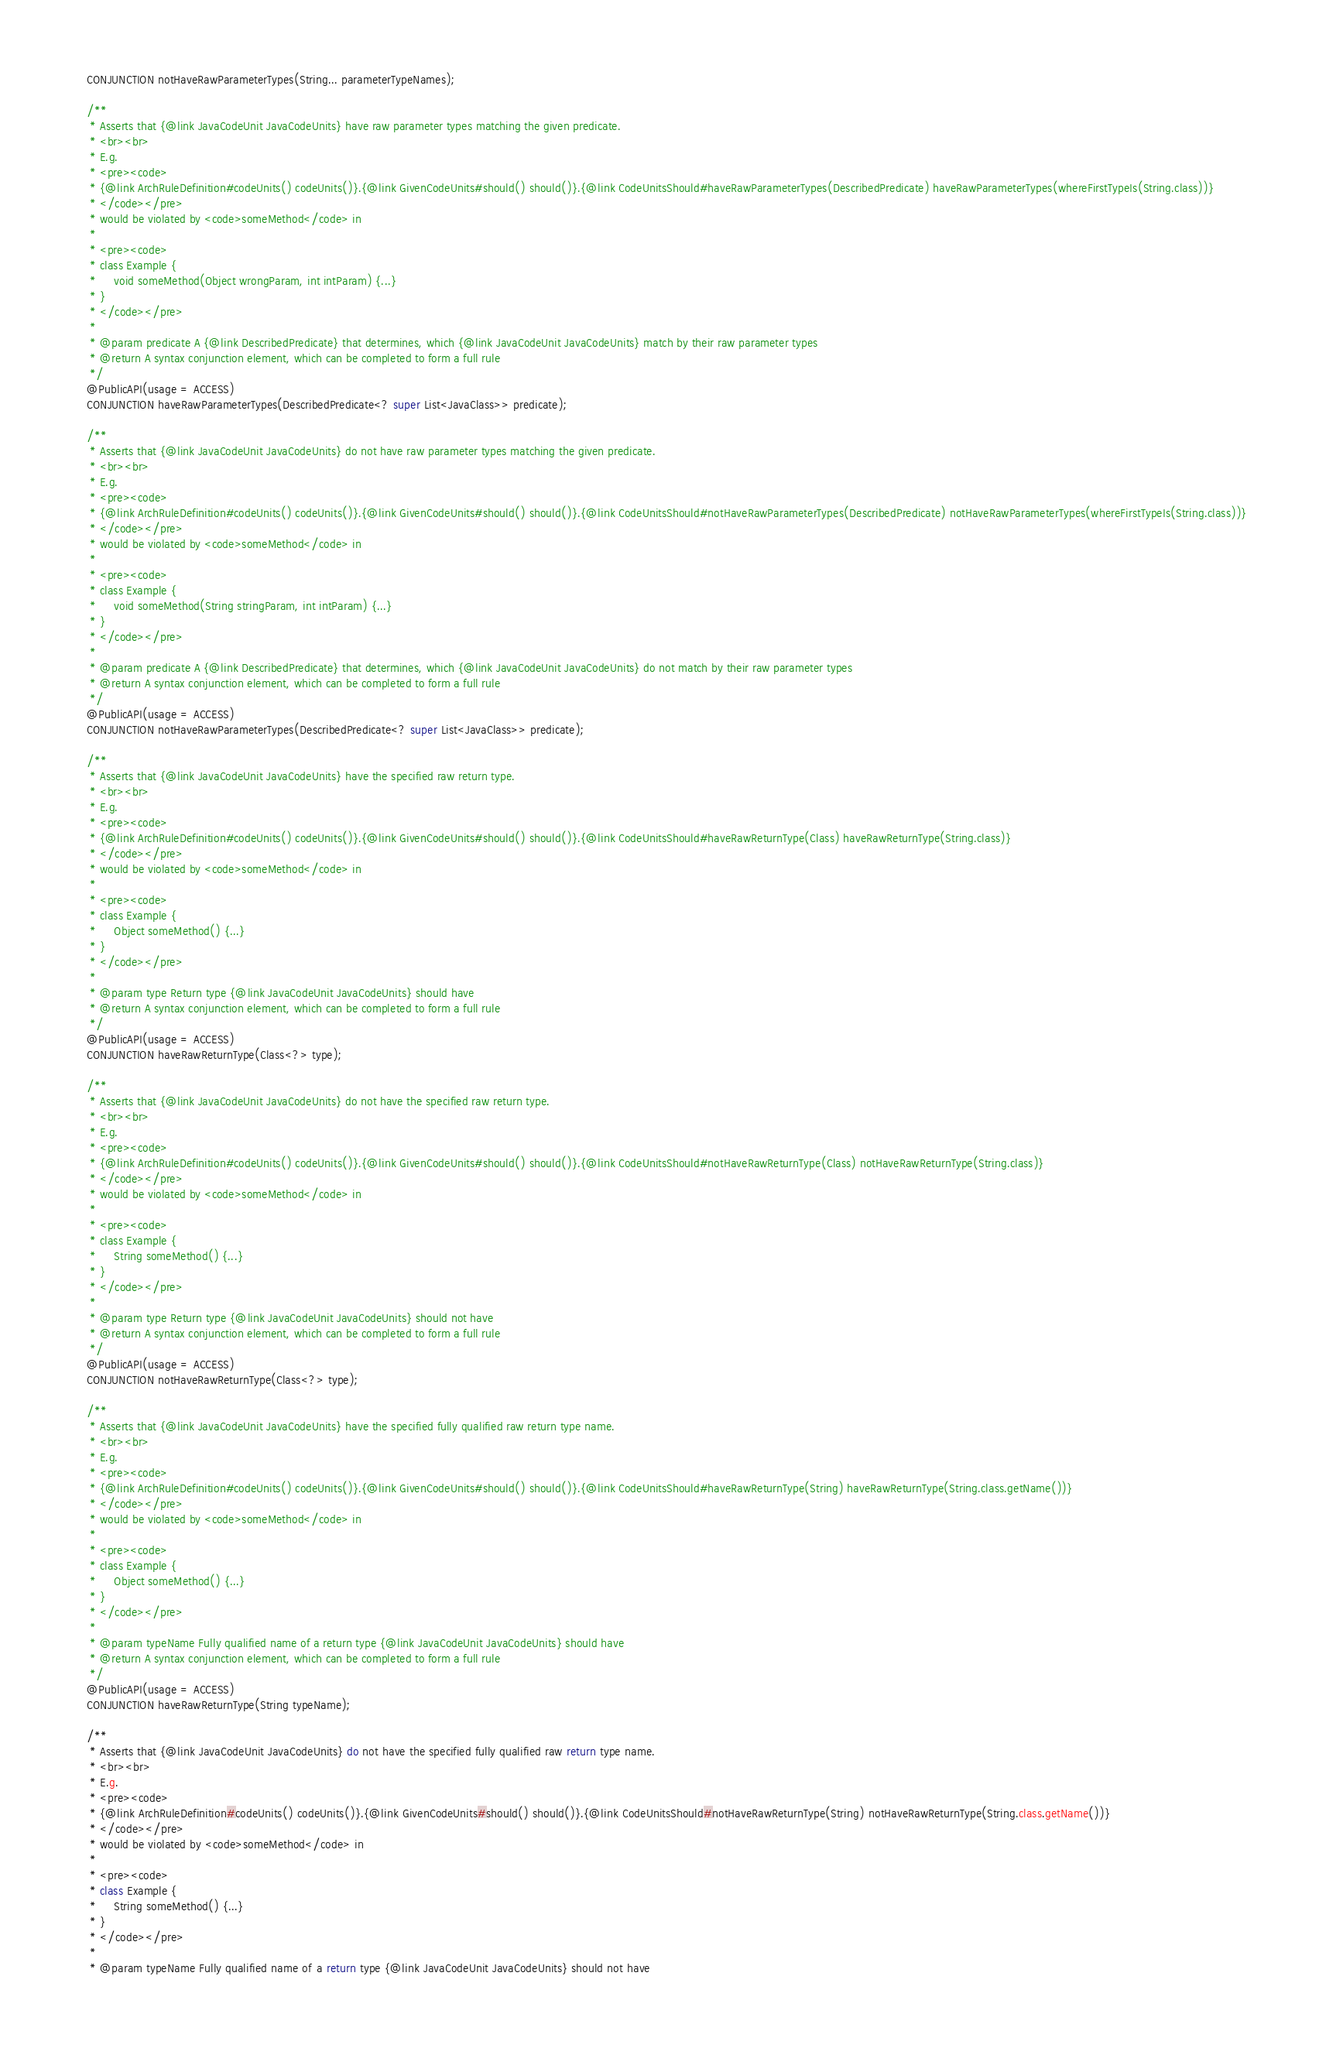Convert code to text. <code><loc_0><loc_0><loc_500><loc_500><_Java_>    CONJUNCTION notHaveRawParameterTypes(String... parameterTypeNames);

    /**
     * Asserts that {@link JavaCodeUnit JavaCodeUnits} have raw parameter types matching the given predicate.
     * <br><br>
     * E.g.
     * <pre><code>
     * {@link ArchRuleDefinition#codeUnits() codeUnits()}.{@link GivenCodeUnits#should() should()}.{@link CodeUnitsShould#haveRawParameterTypes(DescribedPredicate) haveRawParameterTypes(whereFirstTypeIs(String.class))}
     * </code></pre>
     * would be violated by <code>someMethod</code> in
     *
     * <pre><code>
     * class Example {
     *     void someMethod(Object wrongParam, int intParam) {...}
     * }
     * </code></pre>
     *
     * @param predicate A {@link DescribedPredicate} that determines, which {@link JavaCodeUnit JavaCodeUnits} match by their raw parameter types
     * @return A syntax conjunction element, which can be completed to form a full rule
     */
    @PublicAPI(usage = ACCESS)
    CONJUNCTION haveRawParameterTypes(DescribedPredicate<? super List<JavaClass>> predicate);

    /**
     * Asserts that {@link JavaCodeUnit JavaCodeUnits} do not have raw parameter types matching the given predicate.
     * <br><br>
     * E.g.
     * <pre><code>
     * {@link ArchRuleDefinition#codeUnits() codeUnits()}.{@link GivenCodeUnits#should() should()}.{@link CodeUnitsShould#notHaveRawParameterTypes(DescribedPredicate) notHaveRawParameterTypes(whereFirstTypeIs(String.class))}
     * </code></pre>
     * would be violated by <code>someMethod</code> in
     *
     * <pre><code>
     * class Example {
     *     void someMethod(String stringParam, int intParam) {...}
     * }
     * </code></pre>
     *
     * @param predicate A {@link DescribedPredicate} that determines, which {@link JavaCodeUnit JavaCodeUnits} do not match by their raw parameter types
     * @return A syntax conjunction element, which can be completed to form a full rule
     */
    @PublicAPI(usage = ACCESS)
    CONJUNCTION notHaveRawParameterTypes(DescribedPredicate<? super List<JavaClass>> predicate);

    /**
     * Asserts that {@link JavaCodeUnit JavaCodeUnits} have the specified raw return type.
     * <br><br>
     * E.g.
     * <pre><code>
     * {@link ArchRuleDefinition#codeUnits() codeUnits()}.{@link GivenCodeUnits#should() should()}.{@link CodeUnitsShould#haveRawReturnType(Class) haveRawReturnType(String.class)}
     * </code></pre>
     * would be violated by <code>someMethod</code> in
     *
     * <pre><code>
     * class Example {
     *     Object someMethod() {...}
     * }
     * </code></pre>
     *
     * @param type Return type {@link JavaCodeUnit JavaCodeUnits} should have
     * @return A syntax conjunction element, which can be completed to form a full rule
     */
    @PublicAPI(usage = ACCESS)
    CONJUNCTION haveRawReturnType(Class<?> type);

    /**
     * Asserts that {@link JavaCodeUnit JavaCodeUnits} do not have the specified raw return type.
     * <br><br>
     * E.g.
     * <pre><code>
     * {@link ArchRuleDefinition#codeUnits() codeUnits()}.{@link GivenCodeUnits#should() should()}.{@link CodeUnitsShould#notHaveRawReturnType(Class) notHaveRawReturnType(String.class)}
     * </code></pre>
     * would be violated by <code>someMethod</code> in
     *
     * <pre><code>
     * class Example {
     *     String someMethod() {...}
     * }
     * </code></pre>
     *
     * @param type Return type {@link JavaCodeUnit JavaCodeUnits} should not have
     * @return A syntax conjunction element, which can be completed to form a full rule
     */
    @PublicAPI(usage = ACCESS)
    CONJUNCTION notHaveRawReturnType(Class<?> type);

    /**
     * Asserts that {@link JavaCodeUnit JavaCodeUnits} have the specified fully qualified raw return type name.
     * <br><br>
     * E.g.
     * <pre><code>
     * {@link ArchRuleDefinition#codeUnits() codeUnits()}.{@link GivenCodeUnits#should() should()}.{@link CodeUnitsShould#haveRawReturnType(String) haveRawReturnType(String.class.getName())}
     * </code></pre>
     * would be violated by <code>someMethod</code> in
     *
     * <pre><code>
     * class Example {
     *     Object someMethod() {...}
     * }
     * </code></pre>
     *
     * @param typeName Fully qualified name of a return type {@link JavaCodeUnit JavaCodeUnits} should have
     * @return A syntax conjunction element, which can be completed to form a full rule
     */
    @PublicAPI(usage = ACCESS)
    CONJUNCTION haveRawReturnType(String typeName);

    /**
     * Asserts that {@link JavaCodeUnit JavaCodeUnits} do not have the specified fully qualified raw return type name.
     * <br><br>
     * E.g.
     * <pre><code>
     * {@link ArchRuleDefinition#codeUnits() codeUnits()}.{@link GivenCodeUnits#should() should()}.{@link CodeUnitsShould#notHaveRawReturnType(String) notHaveRawReturnType(String.class.getName())}
     * </code></pre>
     * would be violated by <code>someMethod</code> in
     *
     * <pre><code>
     * class Example {
     *     String someMethod() {...}
     * }
     * </code></pre>
     *
     * @param typeName Fully qualified name of a return type {@link JavaCodeUnit JavaCodeUnits} should not have</code> 